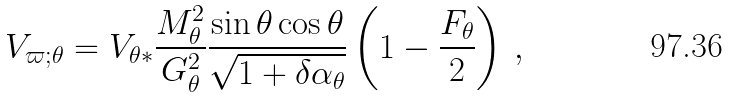<formula> <loc_0><loc_0><loc_500><loc_500>V _ { \varpi ; \theta } = V _ { \theta * } \frac { M _ { \theta } ^ { 2 } } { G _ { \theta } ^ { 2 } } \frac { \sin \theta \cos \theta } { \sqrt { 1 + \delta \alpha _ { \theta } } } \left ( 1 - \frac { F _ { \theta } } { 2 } \right ) \, ,</formula> 